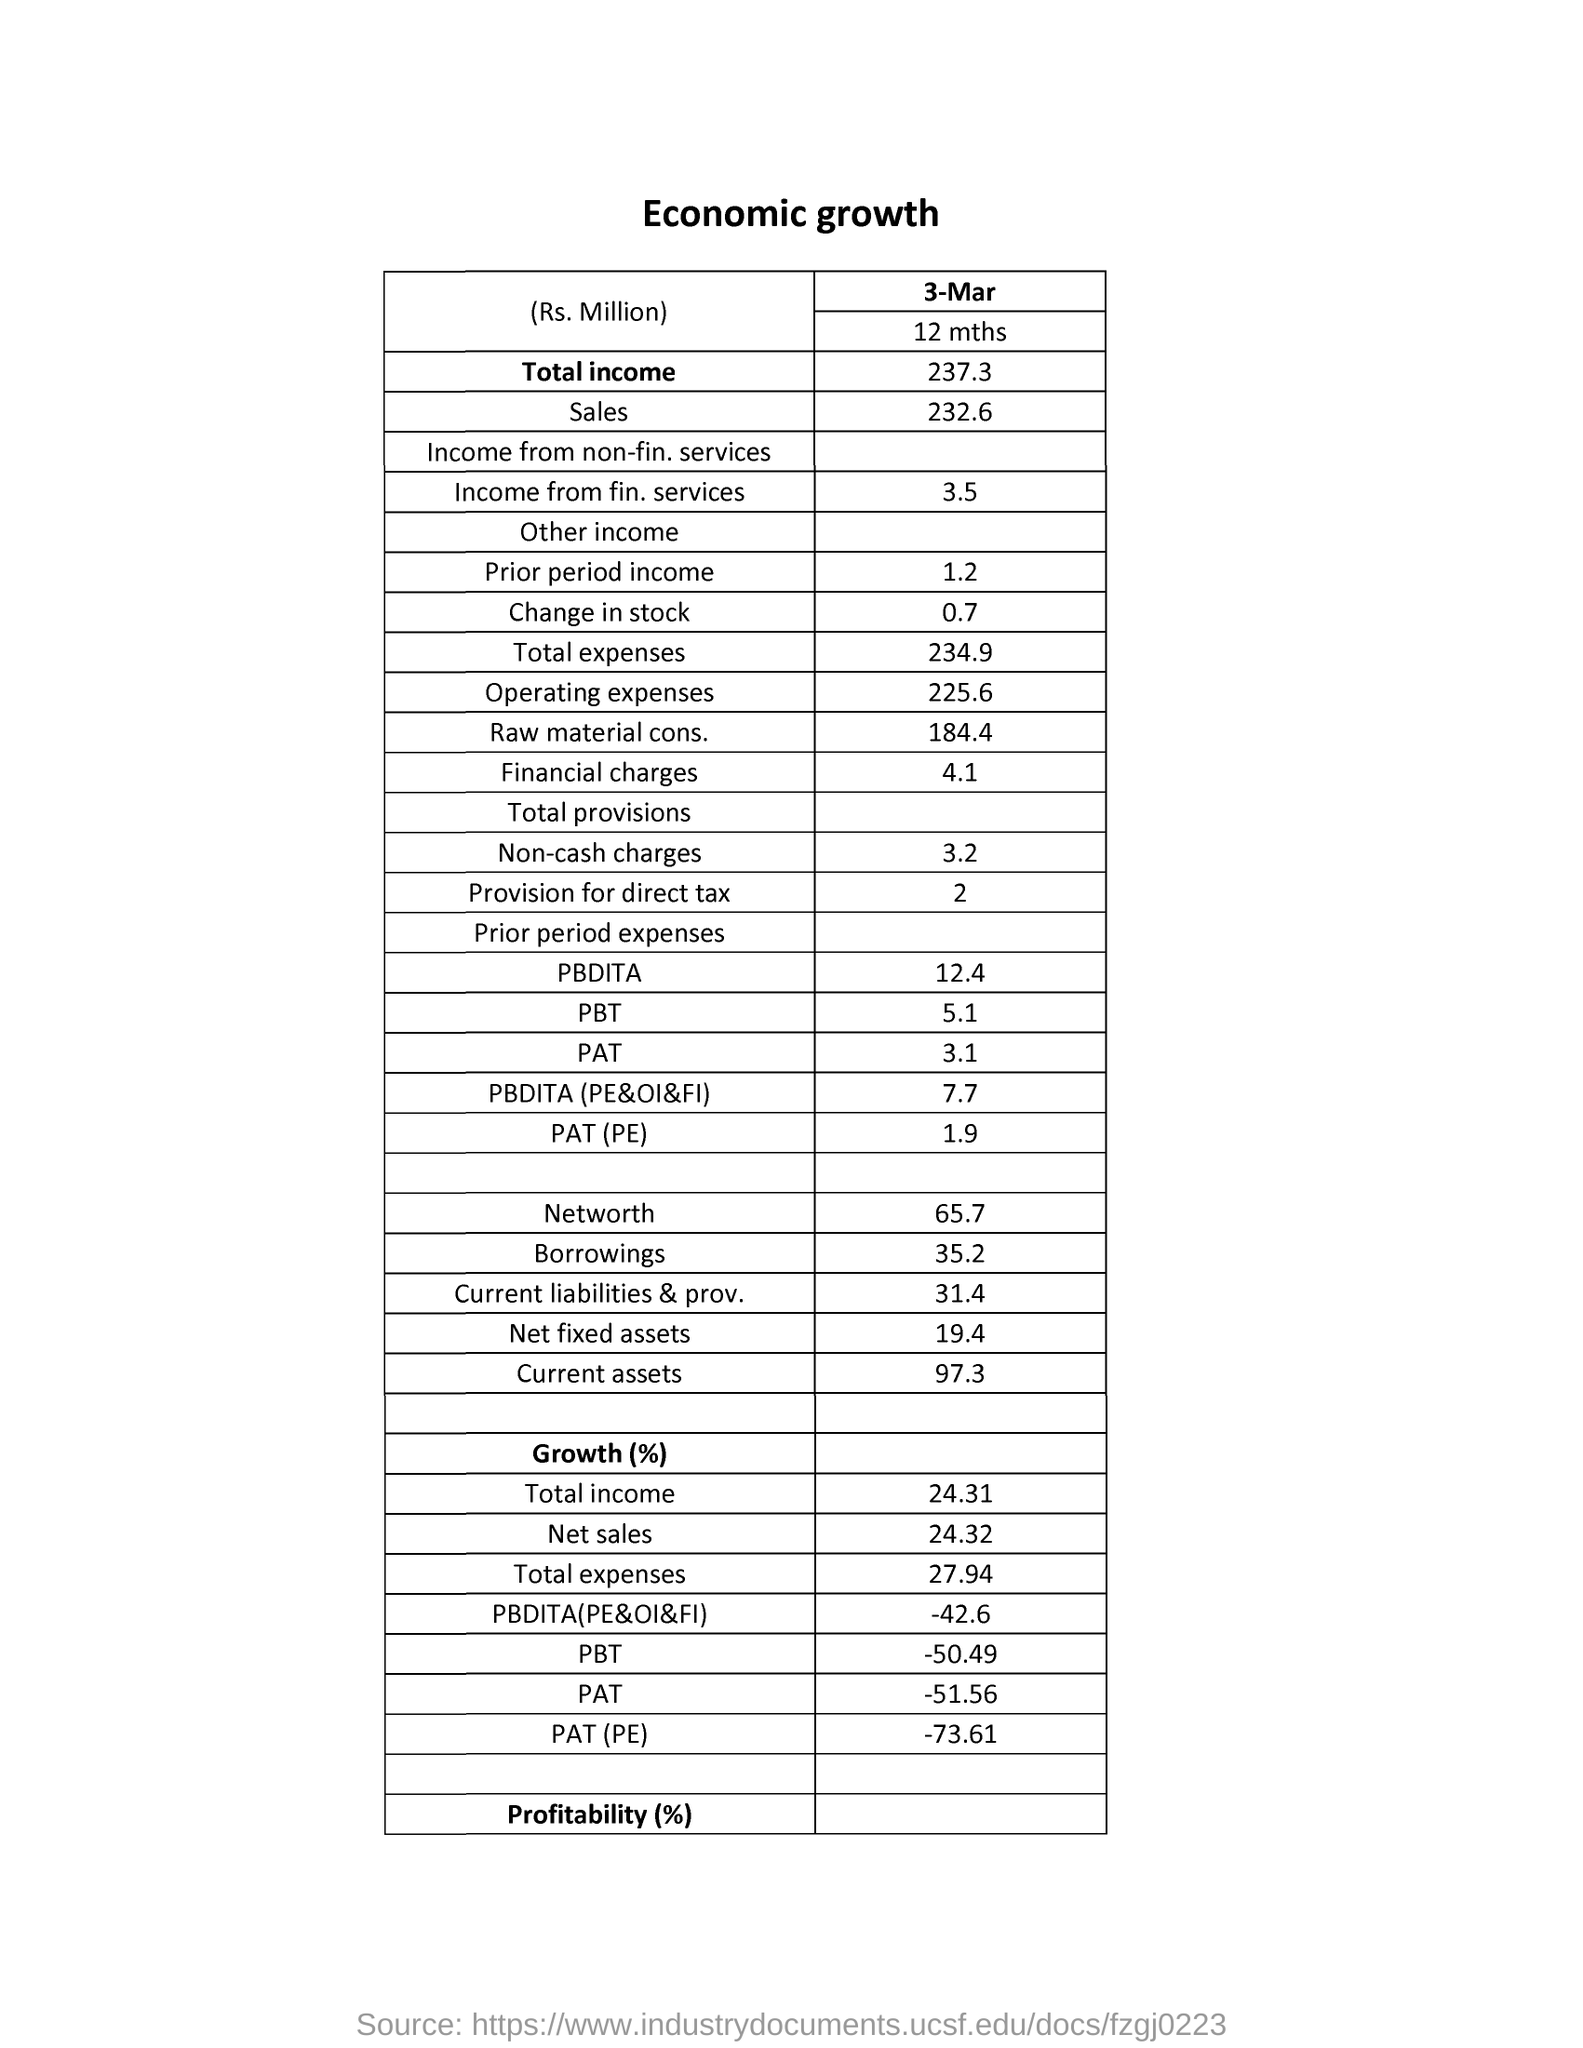Draw attention to some important aspects in this diagram. The name of the table is "Economic growth. On March 3rd, the economic growth was given. 